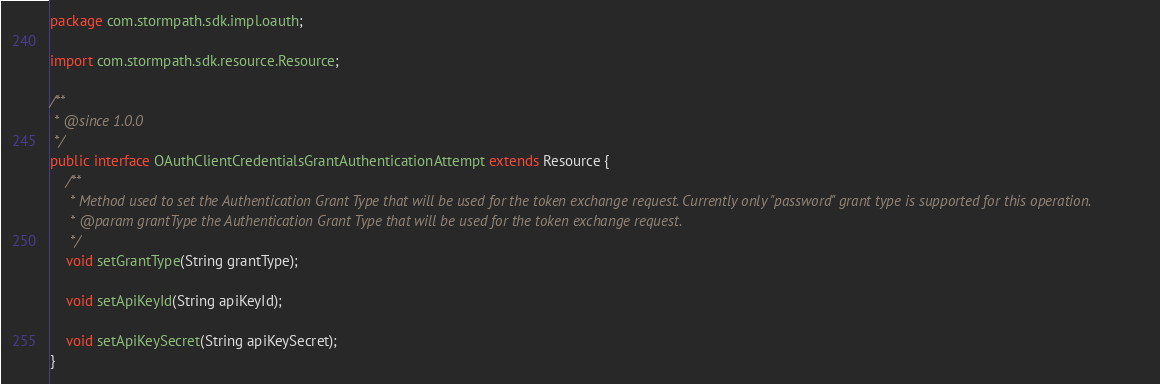<code> <loc_0><loc_0><loc_500><loc_500><_Java_>package com.stormpath.sdk.impl.oauth;

import com.stormpath.sdk.resource.Resource;

/**
 * @since 1.0.0
 */
public interface OAuthClientCredentialsGrantAuthenticationAttempt extends Resource {
    /**
     * Method used to set the Authentication Grant Type that will be used for the token exchange request. Currently only "password" grant type is supported for this operation.
     * @param grantType the Authentication Grant Type that will be used for the token exchange request.
     */
    void setGrantType(String grantType);

    void setApiKeyId(String apiKeyId);

    void setApiKeySecret(String apiKeySecret);
}
</code> 